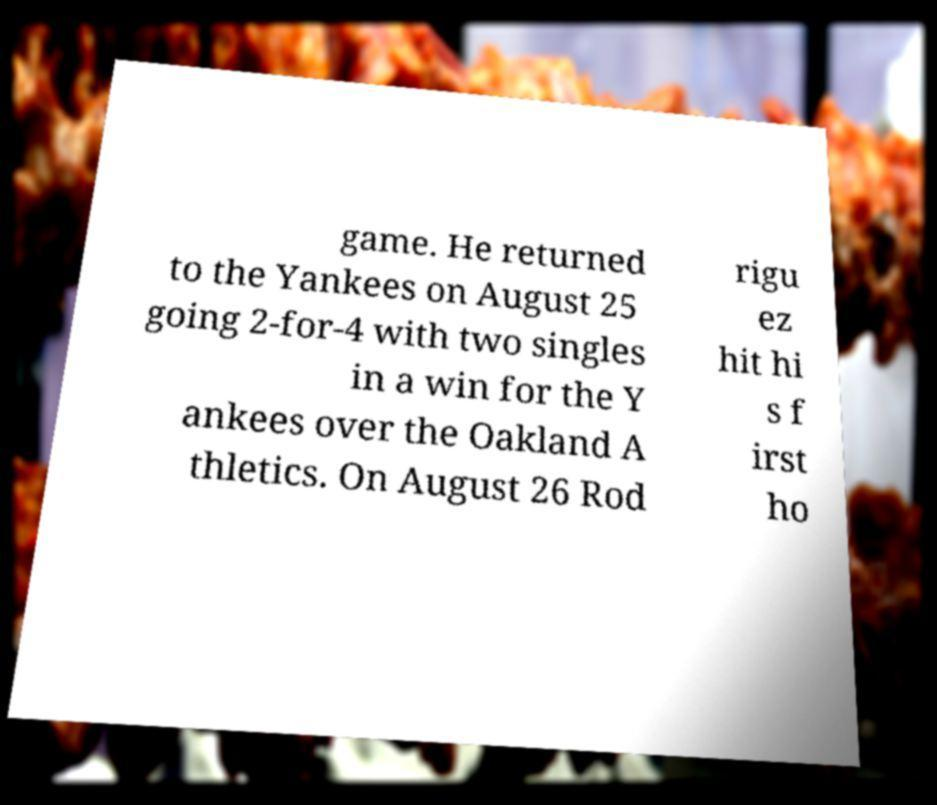Can you accurately transcribe the text from the provided image for me? game. He returned to the Yankees on August 25 going 2-for-4 with two singles in a win for the Y ankees over the Oakland A thletics. On August 26 Rod rigu ez hit hi s f irst ho 